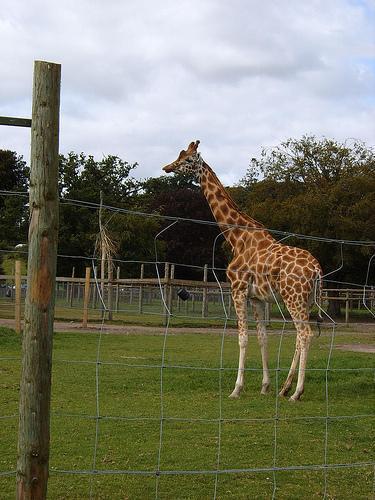How many giraffes are in the photo?
Give a very brief answer. 1. 